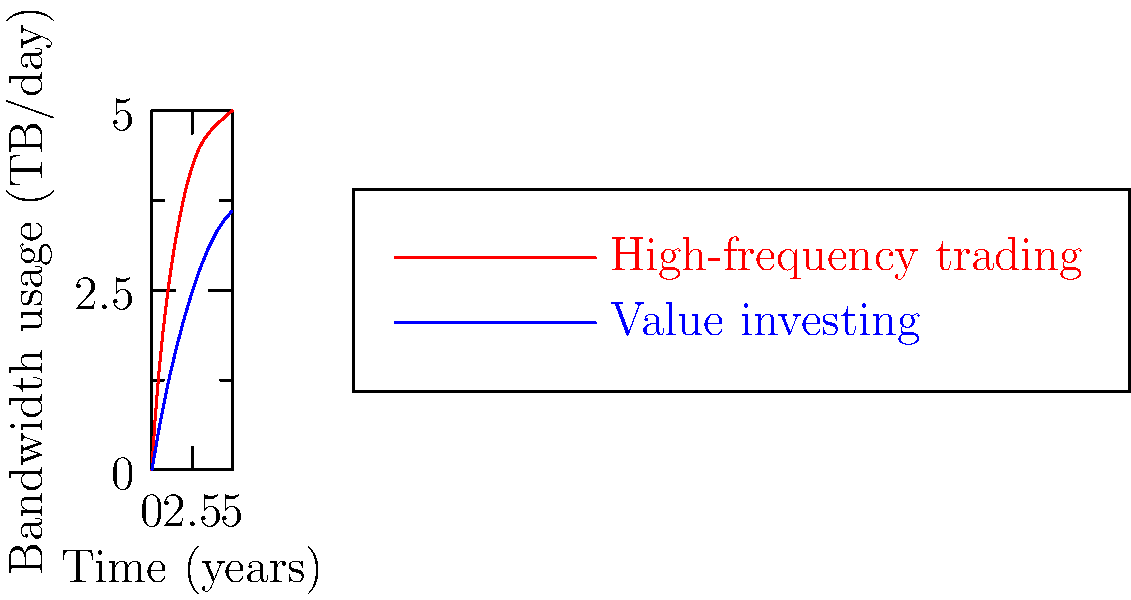Based on the graph showing bandwidth usage over time for high-frequency trading and value investing strategies, which approach demonstrates higher efficiency in terms of bandwidth utilization relative to potential returns after 5 years? To determine the efficiency of bandwidth utilization relative to potential returns, we need to analyze the graph and consider the characteristics of each investment strategy:

1. High-frequency trading (HFT):
   - Represented by the red curve
   - Shows rapid increase in bandwidth usage, reaching ~5 TB/day after 5 years
   - Known for generating small profits from numerous trades

2. Value investing:
   - Represented by the blue curve
   - Shows slower increase in bandwidth usage, reaching ~3.6 TB/day after 5 years
   - Focuses on long-term growth and fundamentals

3. Efficiency analysis:
   a. Bandwidth usage:
      - HFT uses significantly more bandwidth (5 TB/day vs 3.6 TB/day)
      - Value investing uses ~28% less bandwidth after 5 years

   b. Potential returns:
      - HFT generates frequent small profits but faces higher operational costs
      - Value investing aims for larger, long-term gains with lower operational costs

   c. Risk consideration:
      - HFT is more susceptible to market volatility and technical issues
      - Value investing is generally considered less risky due to its long-term approach

4. Efficiency evaluation:
   - Value investing uses less bandwidth while potentially offering similar or better returns
   - Lower bandwidth usage translates to lower operational costs
   - Reduced risk profile of value investing contributes to overall efficiency

Considering these factors, value investing demonstrates higher efficiency in terms of bandwidth utilization relative to potential returns after 5 years.
Answer: Value investing 